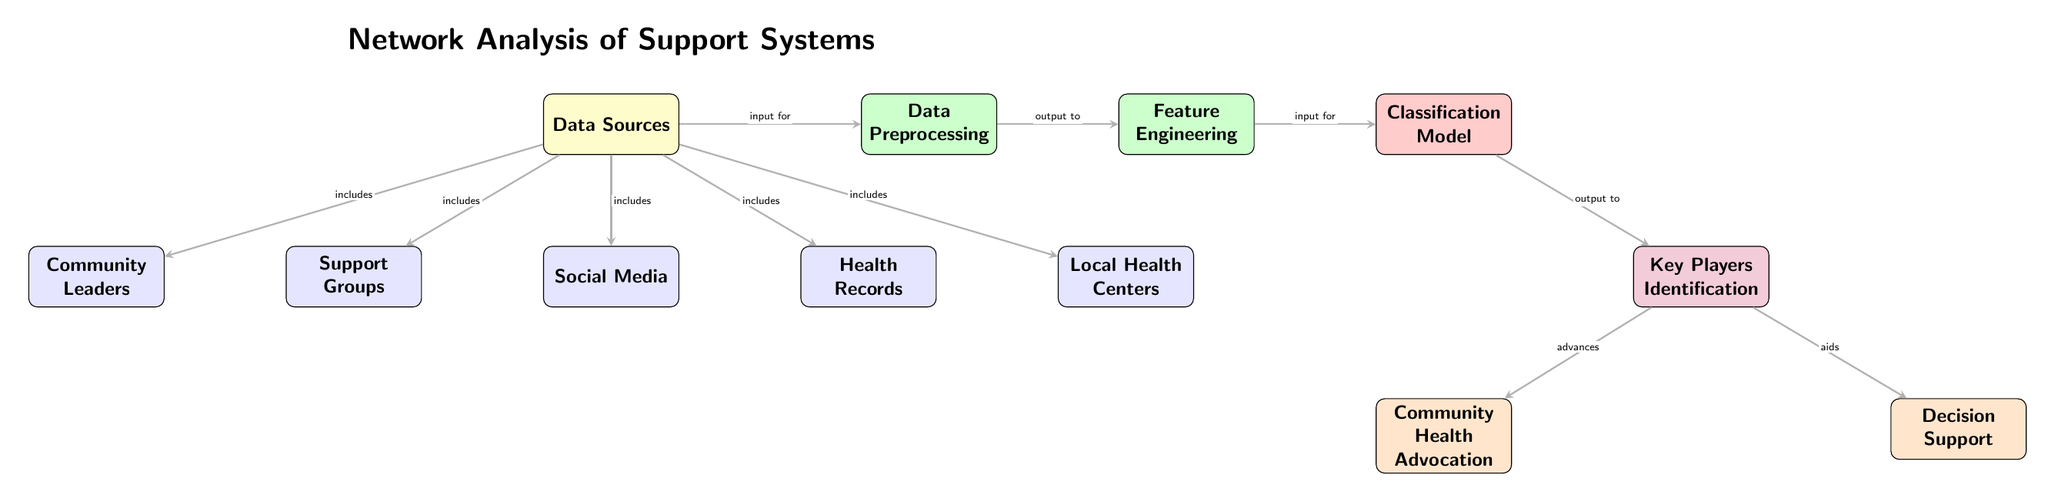What are the inputs for the classification model? The inputs for the classification model come from the feature engineering step, which processes data from the previous steps, specifically from data preprocessing.
Answer: Data preprocessing How many data sources are included in this diagram? There are five data sources depicted in the diagram, which are support groups, social media, health records, community leaders, and local health centers.
Answer: Five Which node follows the feature engineering node? The classification model node directly follows the feature engineering node, representing the step that inputs features for classification.
Answer: Classification Model What is the output of the classification model? The output of the classification model is the key players' identification, indicating which players are significant in the community health context.
Answer: Key Players Identification Which two outputs are generated after identifying the key players? Two outputs generated after identifying the key players are community health advocation and decision support, both of which advance the health advocacy efforts in the community.
Answer: Community Health Advocation, Decision Support What type of data source is associated with community leaders? Community leaders are categorized as one of the data sources, indicating they play a role in providing information relevant for analysis in community health advocacy.
Answer: Data Source Which processing step comes after data preprocessing? The feature engineering step comes immediately after data preprocessing, as it utilizes the preprocessed data to generate features needed for modeling.
Answer: Feature Engineering What relationship is indicated between key players and community health? The relationship indicated is that the identification of key players advances community health advocation, promoting a more effective health advocacy strategy.
Answer: Advances How many edges connect the data sources to the preprocessing node? There are four edges connecting the data sources to the preprocessing node, indicating that each data source feeds into the preprocessing step for further analysis.
Answer: Four 